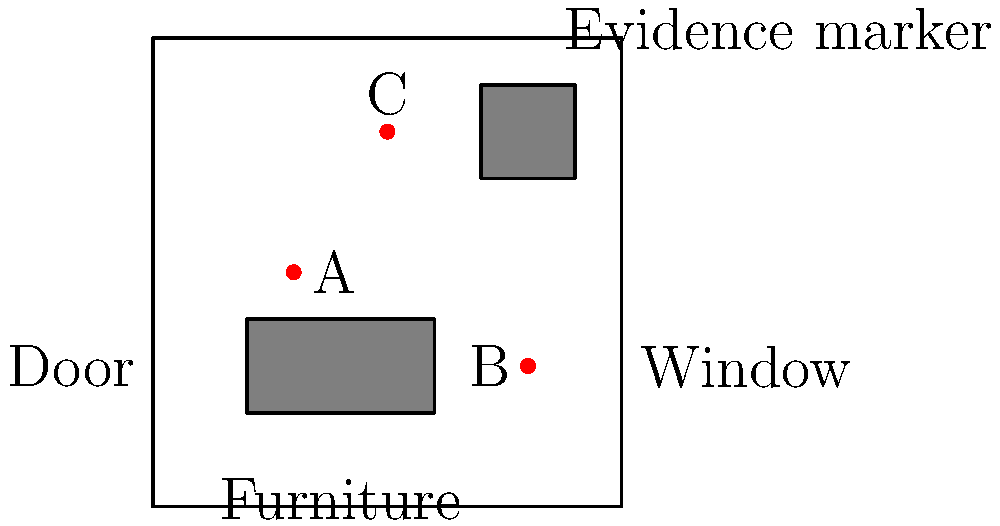In the crime scene photograph above, which evidence marker is most likely to indicate the location of the murder weapon, considering its proximity to key elements in the room? To determine the most likely location of the murder weapon, we need to analyze the crime scene layout and the position of evidence markers:

1. Marker A is located near the center of the room, away from furniture and entry/exit points.
2. Marker B is positioned close to the window, which could be a potential entry or exit point for the perpetrator.
3. Marker C is situated near a piece of furniture in the upper right corner of the room.

Step-by-step analysis:
1. The murder weapon is often found near entry/exit points or in areas where it could be quickly hidden.
2. Windows and doors are common entry/exit points in crime scenes.
3. Furniture can provide hiding spots for weapons.
4. Marker B is closest to the window, making it a prime location for evidence related to entry/exit.
5. The proximity of Marker B to both the window and a potential escape route increases the likelihood of it being associated with the murder weapon.

Given these factors, Marker B is the most likely to indicate the location of the murder weapon due to its strategic position near a potential entry/exit point (the window) and its accessibility for quick disposal or concealment.
Answer: B 